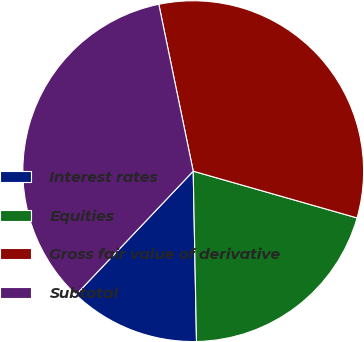Convert chart to OTSL. <chart><loc_0><loc_0><loc_500><loc_500><pie_chart><fcel>Interest rates<fcel>Equities<fcel>Gross fair value of derivative<fcel>Subtotal<nl><fcel>12.39%<fcel>20.27%<fcel>32.66%<fcel>34.68%<nl></chart> 